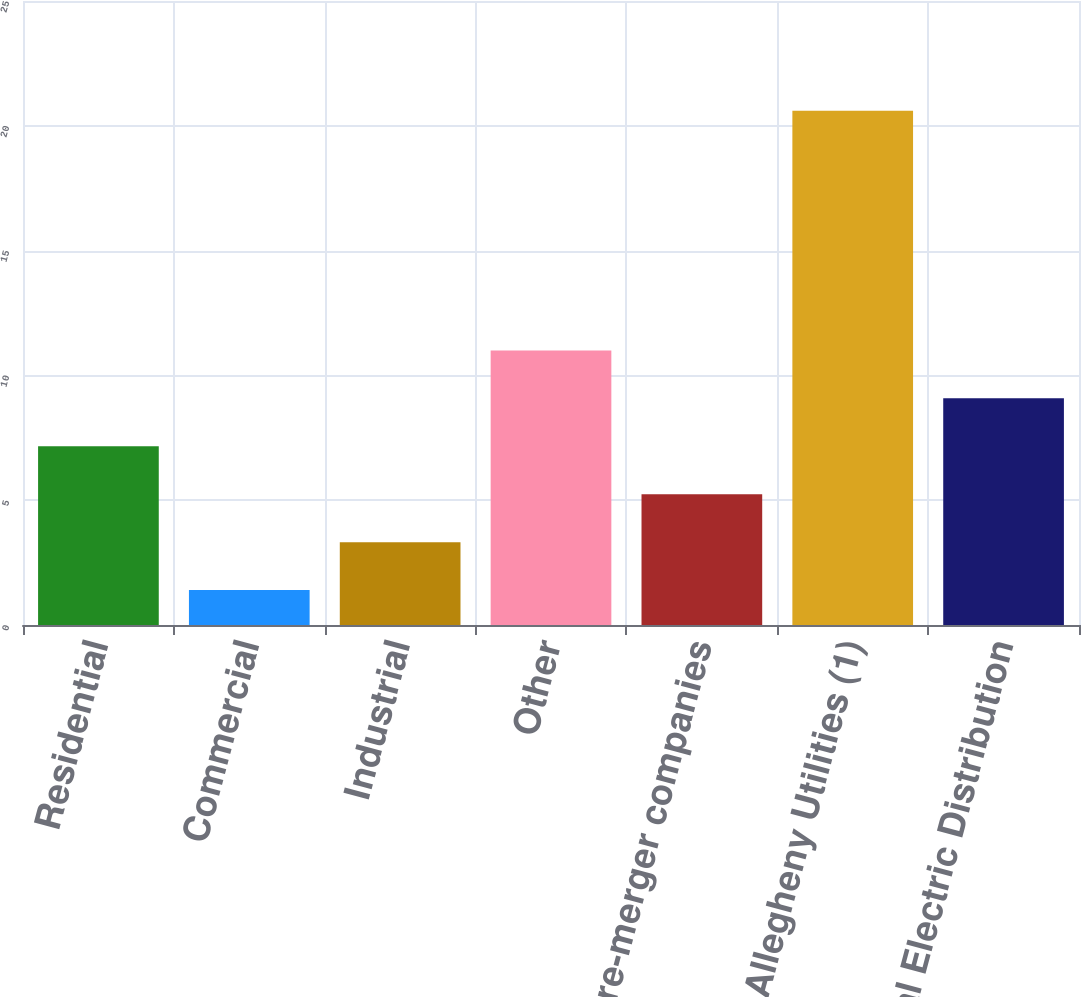<chart> <loc_0><loc_0><loc_500><loc_500><bar_chart><fcel>Residential<fcel>Commercial<fcel>Industrial<fcel>Other<fcel>Total pre-merger companies<fcel>Allegheny Utilities (1)<fcel>Total Electric Distribution<nl><fcel>7.16<fcel>1.4<fcel>3.32<fcel>11<fcel>5.24<fcel>20.6<fcel>9.08<nl></chart> 